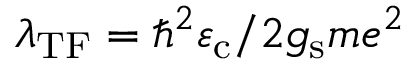Convert formula to latex. <formula><loc_0><loc_0><loc_500><loc_500>\lambda _ { T F } = \hbar { ^ } { 2 } \varepsilon _ { c } / 2 g _ { s } m e ^ { 2 }</formula> 